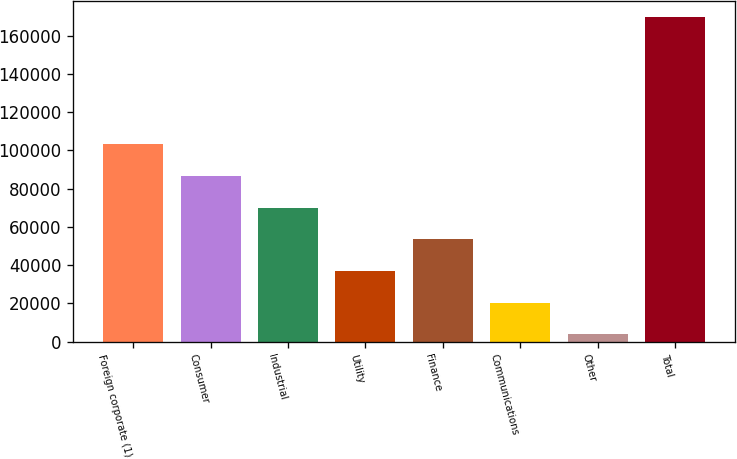<chart> <loc_0><loc_0><loc_500><loc_500><bar_chart><fcel>Foreign corporate (1)<fcel>Consumer<fcel>Industrial<fcel>Utility<fcel>Finance<fcel>Communications<fcel>Other<fcel>Total<nl><fcel>103284<fcel>86700<fcel>70115.8<fcel>36947.4<fcel>53531.6<fcel>20363.2<fcel>3779<fcel>169621<nl></chart> 